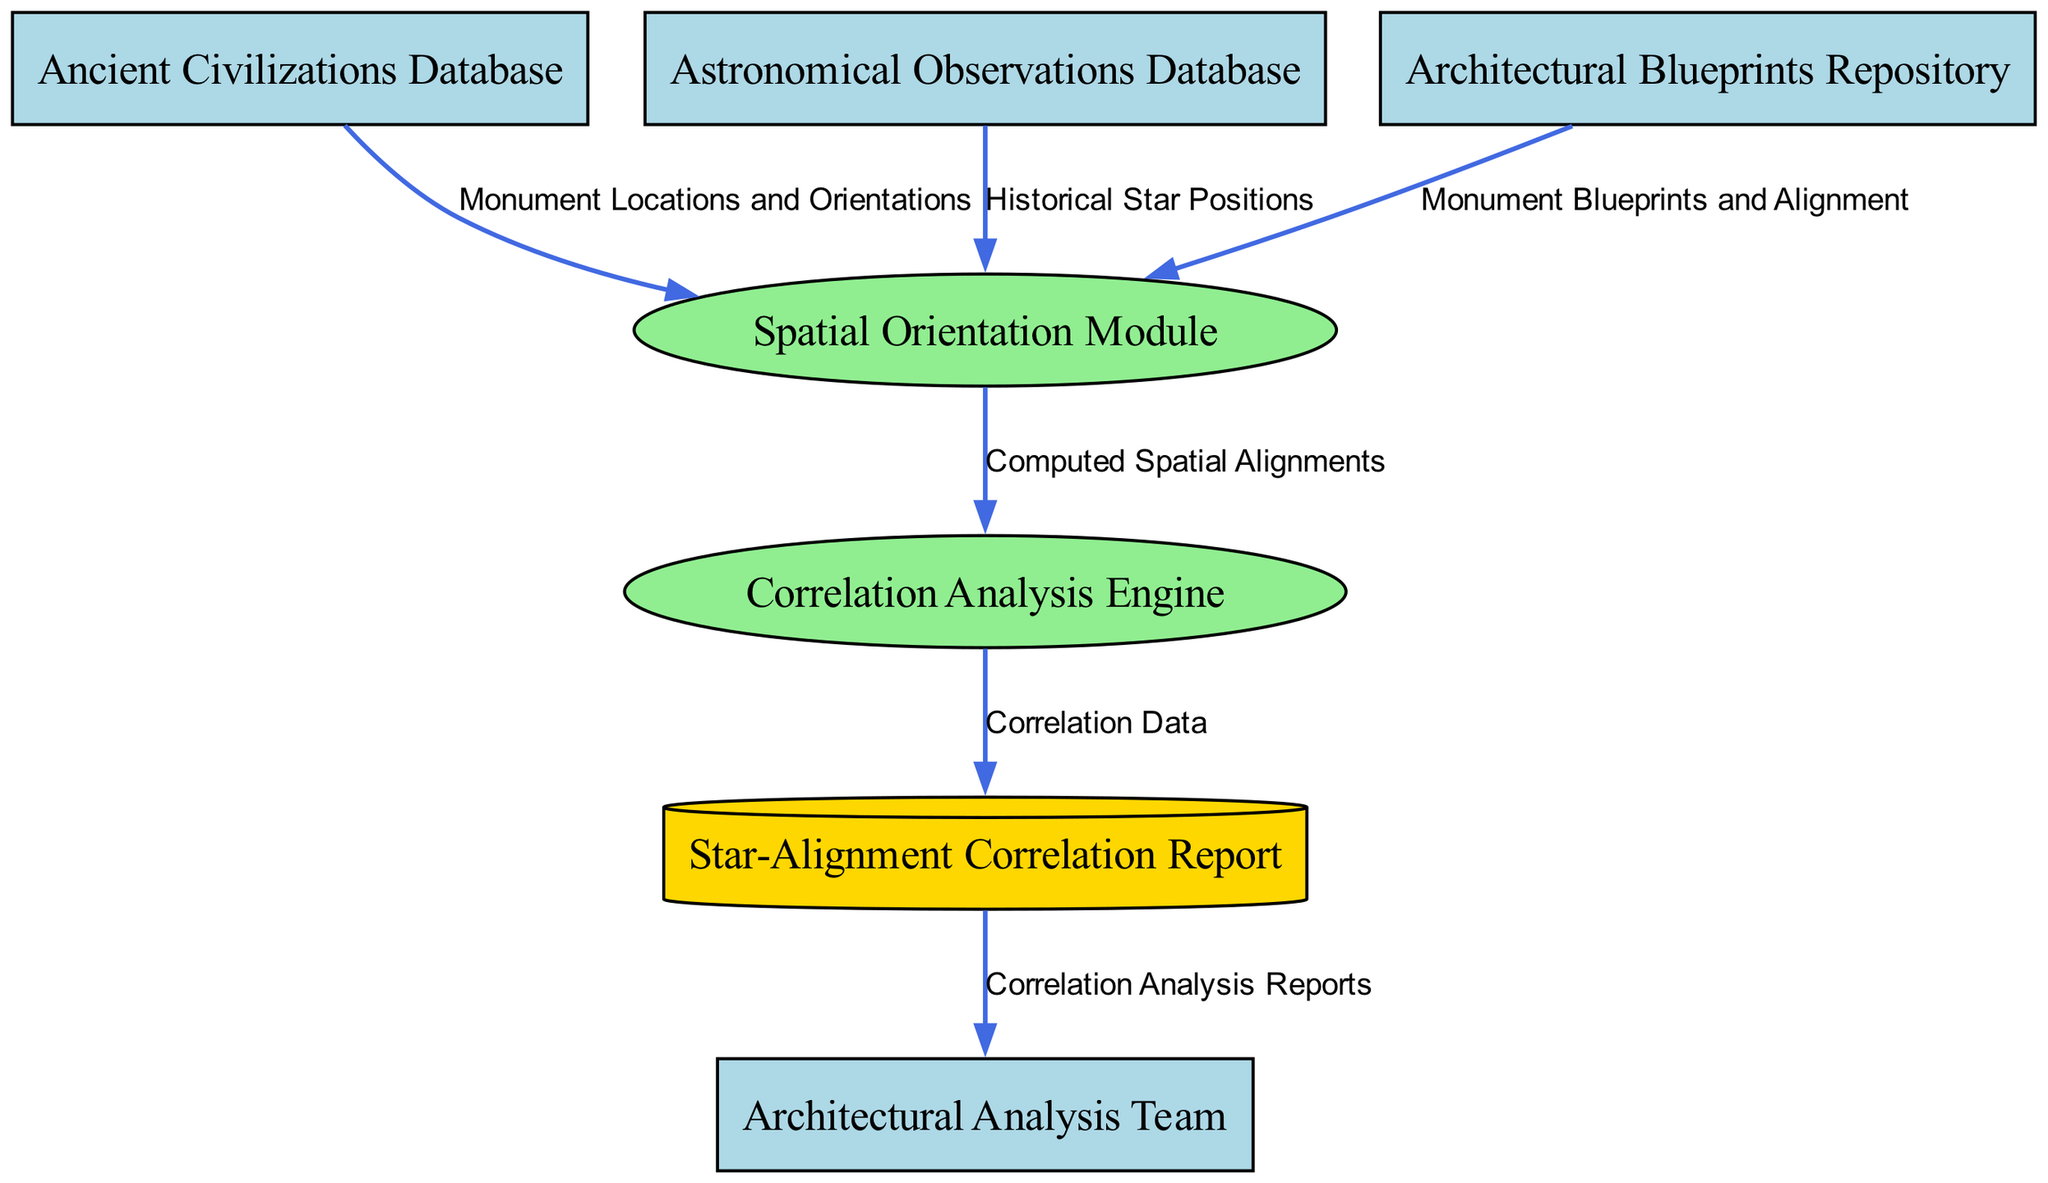What is the first external entity in the diagram? The external entities are listed in the diagram, and the first one mentioned is "Ancient Civilizations Database".
Answer: Ancient Civilizations Database How many processes are depicted in the diagram? By counting the shapes designated as processes, there are two processes shown: "Spatial Orientation Module" and "Correlation Analysis Engine".
Answer: 2 What data flows into the Spatial Orientation Module from the Architectural Blueprints Repository? The data flowing into the Spatial Orientation Module from the Architectural Blueprints Repository is "Monument Blueprints and Alignment".
Answer: Monument Blueprints and Alignment Which entity receives the "Correlation Data"? The "Correlation Data" is sent from the "Correlation Analysis Engine" to the "Star-Alignment Correlation Report", indicating that the report stores this data.
Answer: Star-Alignment Correlation Report What type of data does the Architectural Analysis Team receive? The Architectural Analysis Team receives "Correlation Analysis Reports" which contain insights derived from previous computations and analyses.
Answer: Correlation Analysis Reports What is the role of the Spatial Orientation Module? The Spatial Orientation Module is responsible for calculating the spatial orientation and alignment of monuments relative to star positions, as described in its function.
Answer: Calculate spatial orientation How many data flows originate from the Spatial Orientation Module? The Spatial Orientation Module has one outgoing data flow, which transmits "Computed Spatial Alignments" to the "Correlation Analysis Engine".
Answer: 1 Which two databases provide data to the Spatial Orientation Module? The "Ancient Civilizations Database" and the "Astronomical Observations Database" both provide relevant data to the Spatial Orientation Module for its computations.
Answer: Ancient Civilizations Database, Astronomical Observations Database What is stored in the Star-Alignment Correlation Report? The Star-Alignment Correlation Report stores the "Correlation Data" generated from the Correlation Analysis Engine, providing a place for these insights.
Answer: Correlation Data 